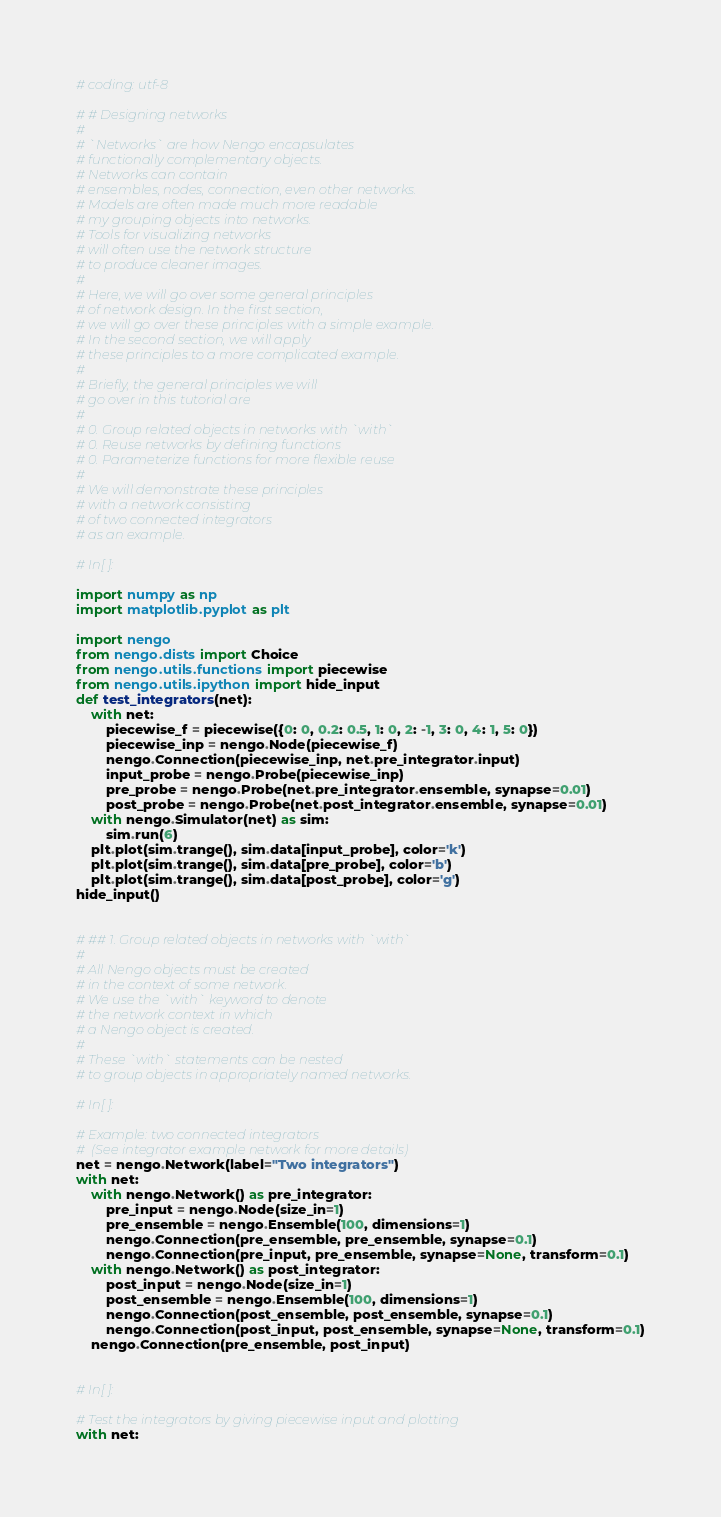Convert code to text. <code><loc_0><loc_0><loc_500><loc_500><_Python_>
# coding: utf-8

# # Designing networks
# 
# `Networks` are how Nengo encapsulates
# functionally complementary objects.
# Networks can contain
# ensembles, nodes, connection, even other networks.
# Models are often made much more readable
# my grouping objects into networks.
# Tools for visualizing networks
# will often use the network structure
# to produce cleaner images.
# 
# Here, we will go over some general principles
# of network design. In the first section,
# we will go over these principles with a simple example.
# In the second section, we will apply
# these principles to a more complicated example.
# 
# Briefly, the general principles we will
# go over in this tutorial are
# 
# 0. Group related objects in networks with `with`
# 0. Reuse networks by defining functions
# 0. Parameterize functions for more flexible reuse
# 
# We will demonstrate these principles
# with a network consisting
# of two connected integrators
# as an example.

# In[ ]:

import numpy as np
import matplotlib.pyplot as plt

import nengo
from nengo.dists import Choice
from nengo.utils.functions import piecewise
from nengo.utils.ipython import hide_input
def test_integrators(net):
    with net:
        piecewise_f = piecewise({0: 0, 0.2: 0.5, 1: 0, 2: -1, 3: 0, 4: 1, 5: 0})
        piecewise_inp = nengo.Node(piecewise_f)
        nengo.Connection(piecewise_inp, net.pre_integrator.input)
        input_probe = nengo.Probe(piecewise_inp)
        pre_probe = nengo.Probe(net.pre_integrator.ensemble, synapse=0.01)
        post_probe = nengo.Probe(net.post_integrator.ensemble, synapse=0.01)
    with nengo.Simulator(net) as sim:
        sim.run(6)
    plt.plot(sim.trange(), sim.data[input_probe], color='k')
    plt.plot(sim.trange(), sim.data[pre_probe], color='b')
    plt.plot(sim.trange(), sim.data[post_probe], color='g')
hide_input()


# ## 1. Group related objects in networks with `with`
# 
# All Nengo objects must be created
# in the context of some network.
# We use the `with` keyword to denote
# the network context in which
# a Nengo object is created.
# 
# These `with` statements can be nested
# to group objects in appropriately named networks.

# In[ ]:

# Example: two connected integrators
#  (See integrator example network for more details)
net = nengo.Network(label="Two integrators")
with net:
    with nengo.Network() as pre_integrator:
        pre_input = nengo.Node(size_in=1)
        pre_ensemble = nengo.Ensemble(100, dimensions=1)
        nengo.Connection(pre_ensemble, pre_ensemble, synapse=0.1)
        nengo.Connection(pre_input, pre_ensemble, synapse=None, transform=0.1)
    with nengo.Network() as post_integrator:
        post_input = nengo.Node(size_in=1)
        post_ensemble = nengo.Ensemble(100, dimensions=1)
        nengo.Connection(post_ensemble, post_ensemble, synapse=0.1)
        nengo.Connection(post_input, post_ensemble, synapse=None, transform=0.1)
    nengo.Connection(pre_ensemble, post_input)


# In[ ]:

# Test the integrators by giving piecewise input and plotting
with net:</code> 